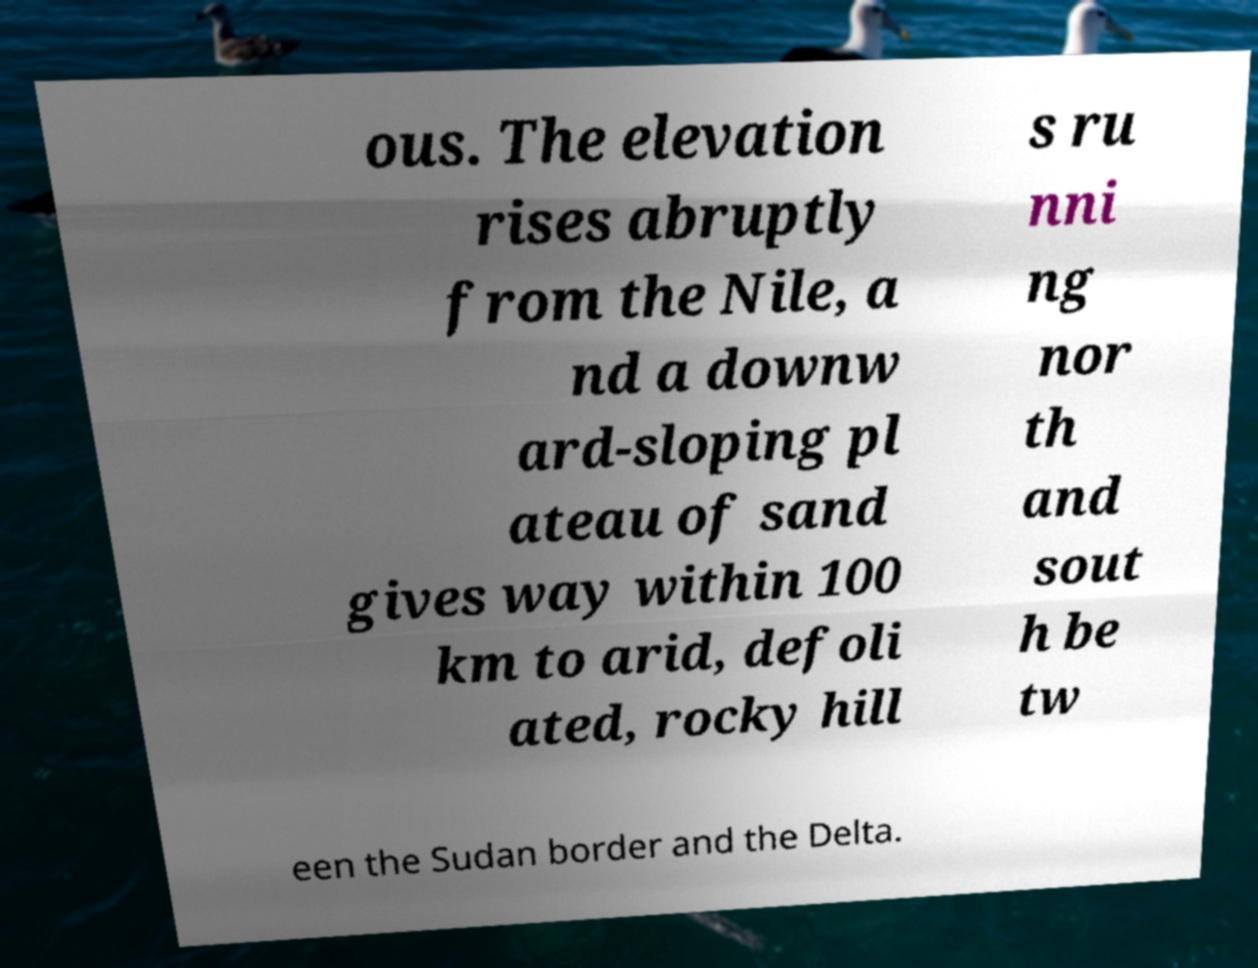Could you extract and type out the text from this image? ous. The elevation rises abruptly from the Nile, a nd a downw ard-sloping pl ateau of sand gives way within 100 km to arid, defoli ated, rocky hill s ru nni ng nor th and sout h be tw een the Sudan border and the Delta. 